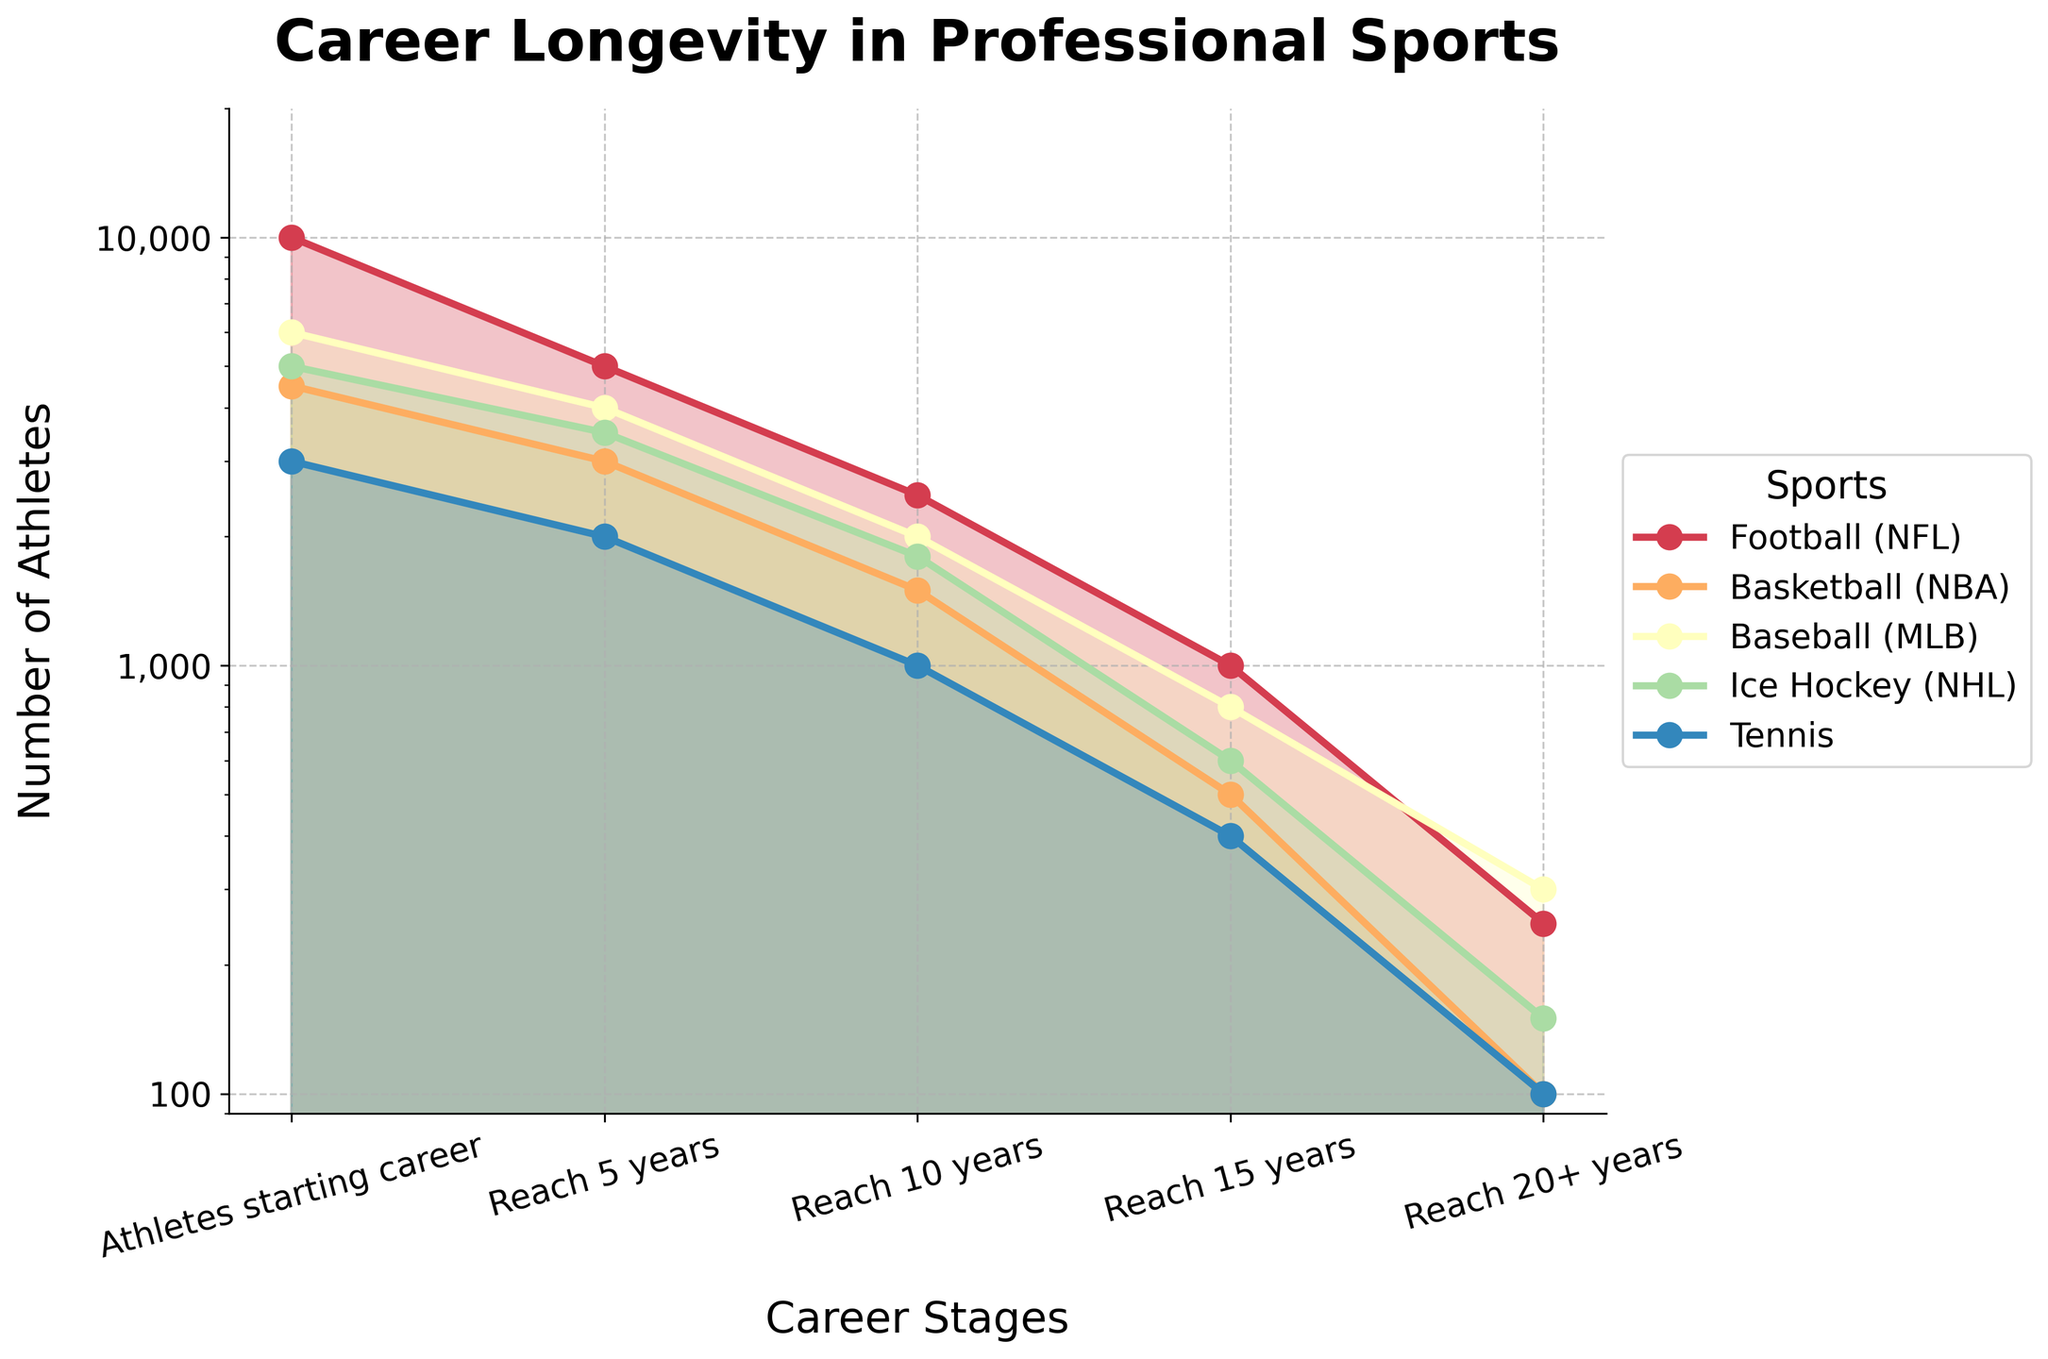What is the title of the figure? The title of the figure is usually located at the top in bold and larger font size. Here, it reads "Career Longevity in Professional Sports."
Answer: Career Longevity in Professional Sports How many different sports are represented in the plot? To identify the number of sports, we look at the legend or the different colored lines in the plot. There are five distinct sports mentioned.
Answer: Five Which sport sees the most significant drop from the starting career stage to reaching 5 years? By examining the sharpness of the decline in values between the "Athletes starting career" and "Reach 5 years" stages for each sport's line, NFL has the most significant drop from 10,000 to 5,000.
Answer: Football (NFL) What is the approximate number of athletes who reach 10 years in Ice Hockey (NHL)? Follow the line or the filled area representing Ice Hockey from the "Athletes starting career" stage through to the "Reach 10 years" stage to find its value, which is marked at around 1,800.
Answer: 1,800 Which sport has the highest number of athletes who reach 20+ years, and how many are there? Compare the values for the "Reach 20+ years" stage across all the sports. MLB baseball has the highest number at the 20+ years mark, with 300 athletes.
Answer: Baseball (MLB), 300 Between Football (NFL) and Tennis, which sport sees a higher attrition rate by the 10-year mark? Calculate the attrition rate as a percentage. NFL starts with 10,000 and drops to 2,500 at 10 years, a 75% attrition rate. Tennis starts with 3,000 and drops to 1,000, a 66.7% attrition rate. The higher rate is for the NFL.
Answer: Football (NFL) What is the difference between the number of athletes reaching 15 years in Basketball (NBA) and Baseball (MLB)? Identify the values at the 15-year stage for both sports: NBA has 500, and MLB has 800. The difference is 800 - 500 = 300.
Answer: 300 Which stages are presented on the x-axis of the chart? The x-axis stages are labeled beneath the corresponding points along the axis. They include "Athletes starting career," "Reach 5 years," "Reach 10 years," "Reach 15 years," and "Reach 20+ years."
Answer: Athletes starting career, Reach 5 years, Reach 10 years, Reach 15 years, Reach 20+ years What does the "log" scale on the y-axis imply about the growth or reduction of the number of athletes over time? A log scale means that equal distances on the axis represent equal ratios, helping us visualize percentage changes rather than absolute differences. It highlights more gradual declines and rapid drops clearly.
Answer: Emphasizes percentage changes, visualizes gradual and sharp changes 